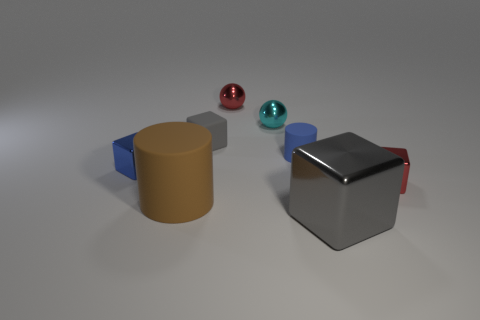Are there fewer blue shiny objects that are in front of the brown cylinder than blue cylinders that are behind the tiny gray object?
Your answer should be compact. No. The other big object that is the same shape as the blue rubber object is what color?
Offer a terse response. Brown. The blue metal object is what size?
Keep it short and to the point. Small. How many red things are the same size as the matte cube?
Give a very brief answer. 2. Do the rubber block and the big metal block have the same color?
Keep it short and to the point. Yes. Is the material of the cube behind the blue metal object the same as the thing in front of the large brown rubber thing?
Ensure brevity in your answer.  No. Is the number of brown matte cylinders greater than the number of big purple cubes?
Ensure brevity in your answer.  Yes. Is there any other thing that is the same color as the large rubber object?
Your response must be concise. No. Is the small blue cylinder made of the same material as the large brown cylinder?
Offer a terse response. Yes. Are there fewer brown matte cylinders than matte things?
Your answer should be very brief. Yes. 